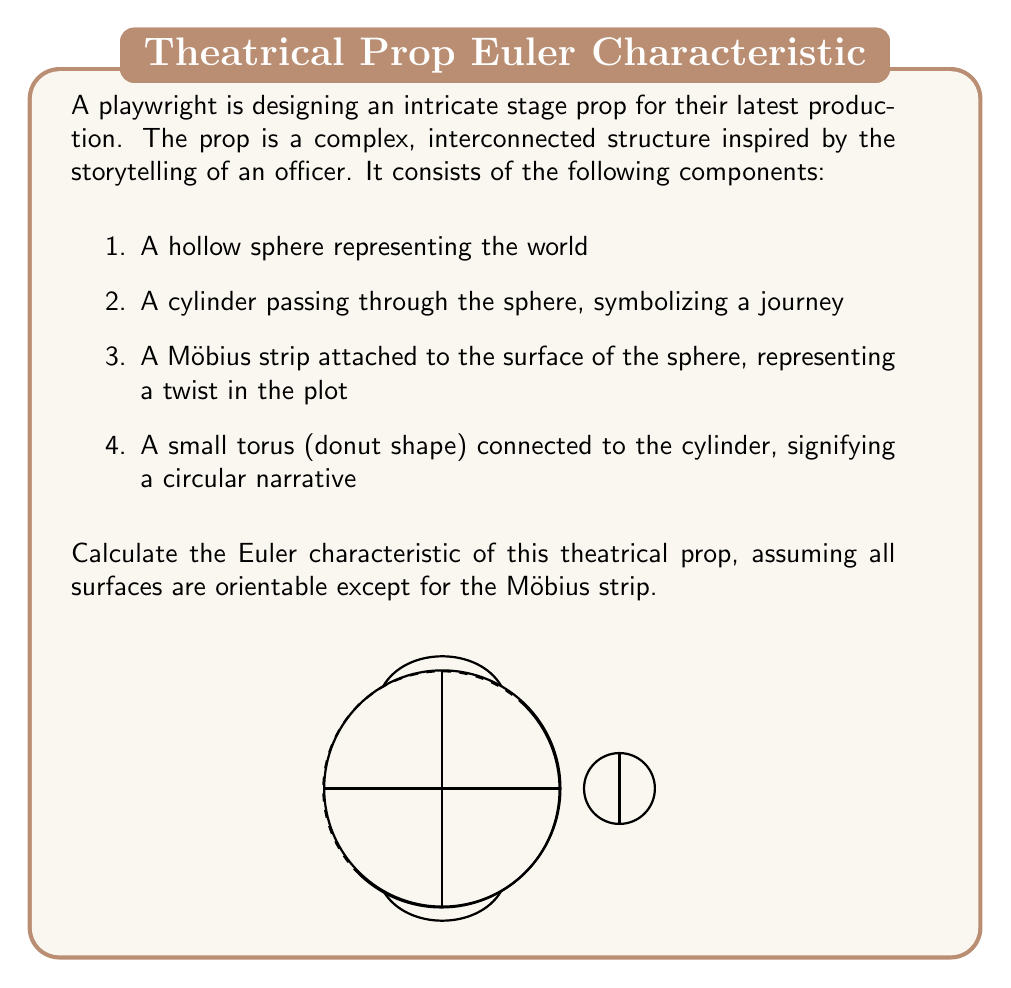Help me with this question. Let's approach this step-by-step:

1) First, recall the formula for the Euler characteristic:

   $$\chi = V - E + F$$

   where $V$ is the number of vertices, $E$ is the number of edges, and $F$ is the number of faces.

2) For closed surfaces, we can use the following Euler characteristics:
   - Sphere: $\chi = 2$
   - Cylinder: $\chi = 0$
   - Torus: $\chi = 0$
   - Möbius strip: $\chi = 0$

3) Now, let's consider each component:
   
   a) Hollow sphere: $\chi_1 = 2$
   
   b) Cylinder: $\chi_2 = 0$
   
   c) Möbius strip: $\chi_3 = 0$
   
   d) Torus: $\chi_4 = 0$

4) When we combine these shapes, we need to account for the intersections:
   
   - The cylinder intersects the sphere along two circles: $-2$
   - The Möbius strip is attached to the sphere along one circle: $-1$
   - The torus is connected to the cylinder along one circle: $-1$

5) The total Euler characteristic is the sum of the individual characteristics minus the intersections:

   $$\chi_{total} = \chi_1 + \chi_2 + \chi_3 + \chi_4 - 2 - 1 - 1$$

6) Substituting the values:

   $$\chi_{total} = 2 + 0 + 0 + 0 - 2 - 1 - 1 = -2$$

Therefore, the Euler characteristic of the theatrical prop is -2.
Answer: $-2$ 